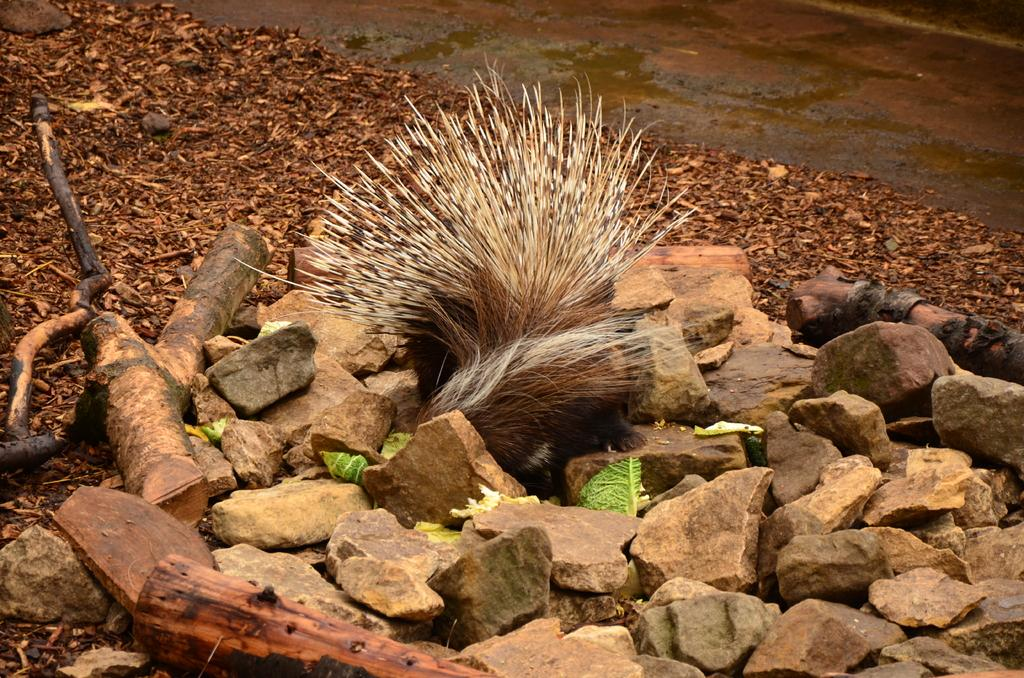What materials are present at the bottom of the image? There are stones and wood at the bottom of the image. What animal can be seen in the middle of the image? There is a porcupine in the middle of the image. What substance can be seen in the background of the image? There is sawdust visible in the background of the image. What type of soap is the porcupine using in the image? There is no soap present in the image, and the porcupine is not using any soap. 